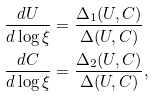<formula> <loc_0><loc_0><loc_500><loc_500>\frac { d U } { d \log \xi } & = \frac { \Delta _ { 1 } ( U , C ) } { \Delta ( U , C ) } \\ \frac { d C } { d \log \xi } & = \frac { \Delta _ { 2 } ( U , C ) } { \Delta ( U , C ) } ,</formula> 